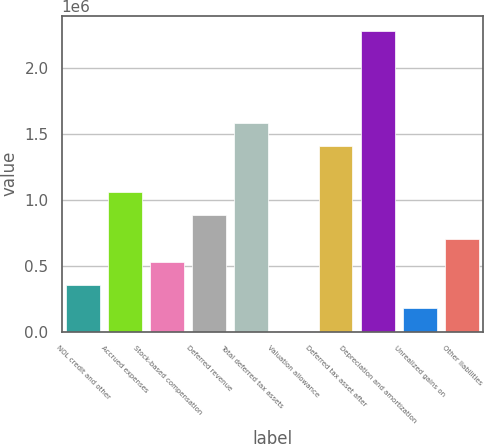Convert chart to OTSL. <chart><loc_0><loc_0><loc_500><loc_500><bar_chart><fcel>NOL credit and other<fcel>Accrued expenses<fcel>Stock-based compensation<fcel>Deferred revenue<fcel>Total deferred tax assets<fcel>Valuation allowance<fcel>Deferred tax asset after<fcel>Depreciation and amortization<fcel>Unrealized gains on<fcel>Other liabilities<nl><fcel>356784<fcel>1.05655e+06<fcel>531725<fcel>881606<fcel>1.58137e+06<fcel>6903<fcel>1.40643e+06<fcel>2.28113e+06<fcel>181844<fcel>706665<nl></chart> 